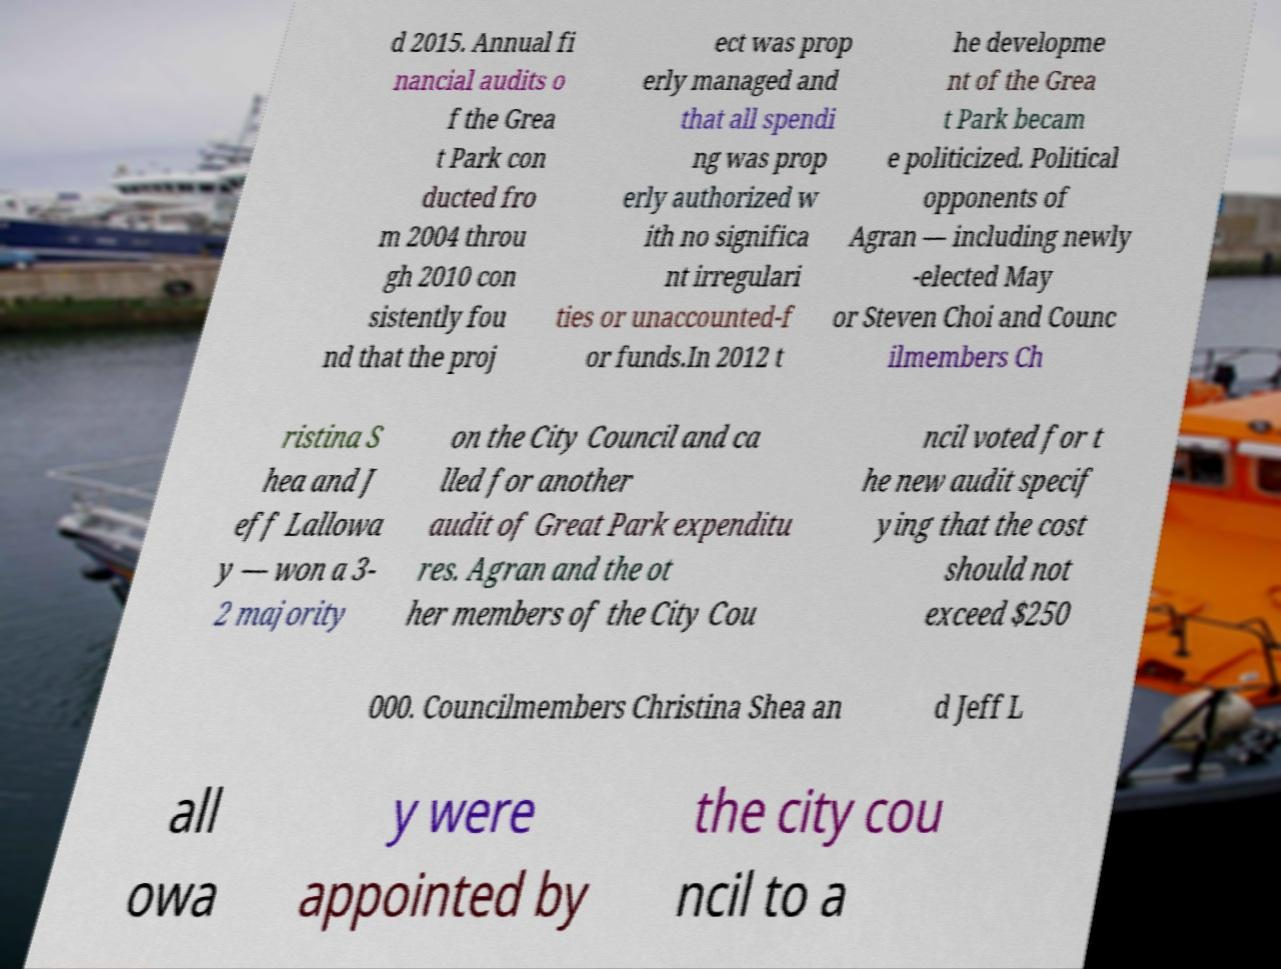Can you read and provide the text displayed in the image?This photo seems to have some interesting text. Can you extract and type it out for me? d 2015. Annual fi nancial audits o f the Grea t Park con ducted fro m 2004 throu gh 2010 con sistently fou nd that the proj ect was prop erly managed and that all spendi ng was prop erly authorized w ith no significa nt irregulari ties or unaccounted-f or funds.In 2012 t he developme nt of the Grea t Park becam e politicized. Political opponents of Agran — including newly -elected May or Steven Choi and Counc ilmembers Ch ristina S hea and J eff Lallowa y — won a 3- 2 majority on the City Council and ca lled for another audit of Great Park expenditu res. Agran and the ot her members of the City Cou ncil voted for t he new audit specif ying that the cost should not exceed $250 000. Councilmembers Christina Shea an d Jeff L all owa y were appointed by the city cou ncil to a 